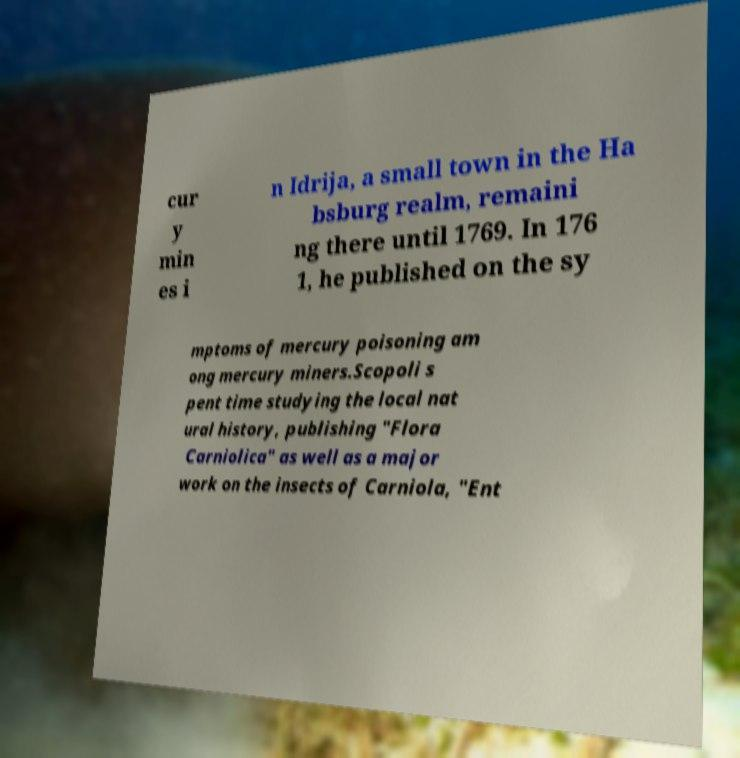I need the written content from this picture converted into text. Can you do that? cur y min es i n Idrija, a small town in the Ha bsburg realm, remaini ng there until 1769. In 176 1, he published on the sy mptoms of mercury poisoning am ong mercury miners.Scopoli s pent time studying the local nat ural history, publishing "Flora Carniolica" as well as a major work on the insects of Carniola, "Ent 